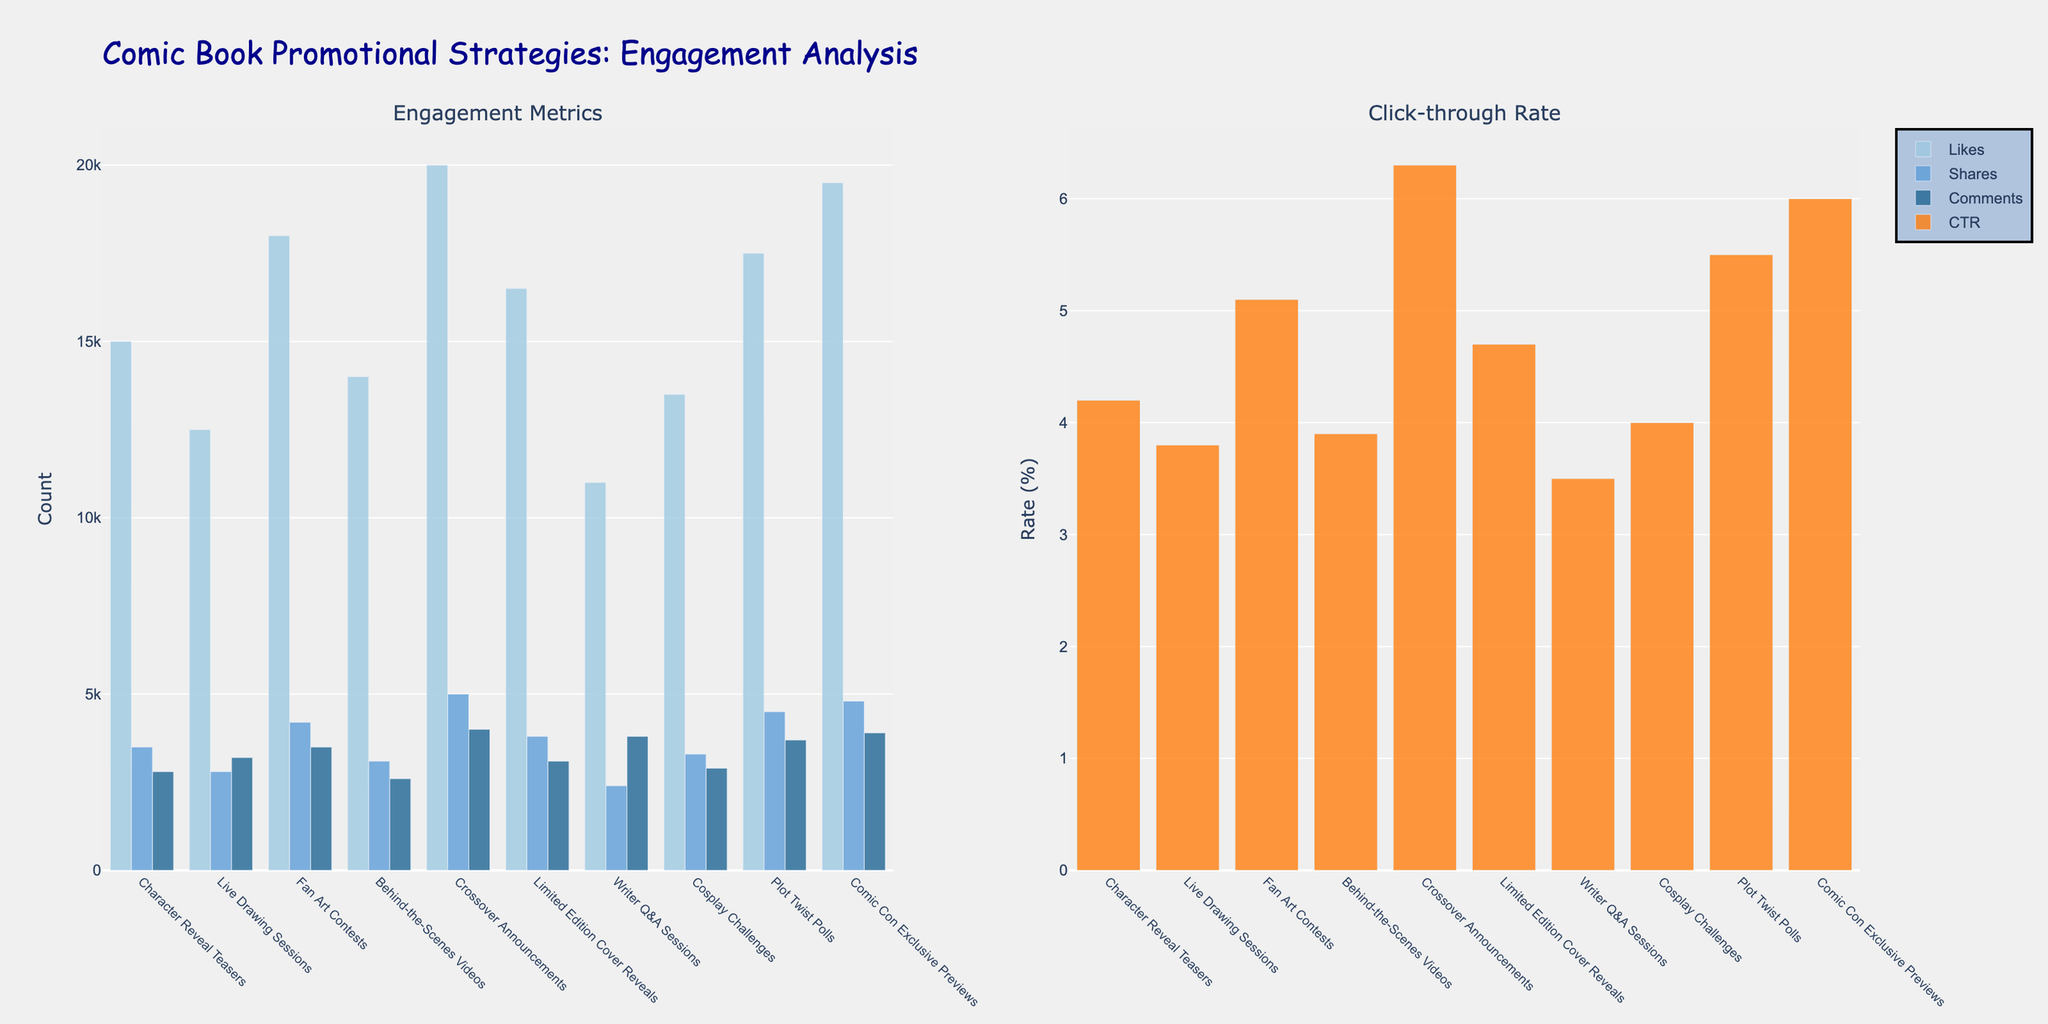Which strategy has the highest number of likes? Find the tallest bar in the likes category (on the left subplot). The crossover announcements bar is the tallest.
Answer: Crossover Announcements Which strategy has the lowest click-through rate? Find the shortest bar in the click-through rate category (on the right subplot). The writer Q&A sessions bar is the shortest.
Answer: Writer Q&A Sessions How many more shares do Fan Art Contests have compared to Live Drawing Sessions? Subtract shares of Live Drawing Sessions (2800) from shares of Fan Art Contests (4200): 4200 - 2800 = 1400.
Answer: 1400 What is the average number of comments across all strategies? Sum the comments for all strategies and divide by the number of strategies: (2800+3200+3500+2600+4000+3100+3800+2900+3700+3900) / 10 = 33500/10 = 3350.
Answer: 3350 Which strategy has an equal number of comments and shares? Identify any bars with the same height for comments and shares. Writer Q&A Sessions has both at 2400.
Answer: Writer Q&A Sessions Which strategy has a higher click-through rate: Plot Twist Polls or Limited Edition Cover Reveals? Compare the heights of the click-through rate bars for both strategies. Plot Twist Polls (5.5) is higher than Limited Edition Cover Reveals (4.7).
Answer: Plot Twist Polls How many strategies have more than 15000 likes? Count the bars in the likes category greater than 15000: Character Reveal Teasers, Fan Art Contests, Crossover Announcements, Limited Edition Cover Reveals, Plot Twist Polls, Comic Con Exclusive Previews.
Answer: 6 Which strategy has the most balanced engagement across likes, shares, and comments? Identify the strategy with bars of similar height across all three categories in the left subplot. Cosplay Challenges has relatively balanced engagement.
Answer: Cosplay Challenges What is the difference in click-through rates between Comic Con Exclusive Previews and Behind-the-Scenes Videos? Subtract the click-through rate of Behind-the-Scenes Videos (3.9) from Comic Con Exclusive Previews (6.0): 6.0 - 3.9 = 2.1.
Answer: 2.1 What is the total number of shares for the strategies with click-through rates above 5.0? Identify strategies with click-through rates above 5.0 (Fan Art Contests, Crossover Announcements, Plot Twist Polls, Comic Con Exclusive Previews). Sum their shares: 4200 + 5000 + 4500 + 4800 = 18500.
Answer: 18500 